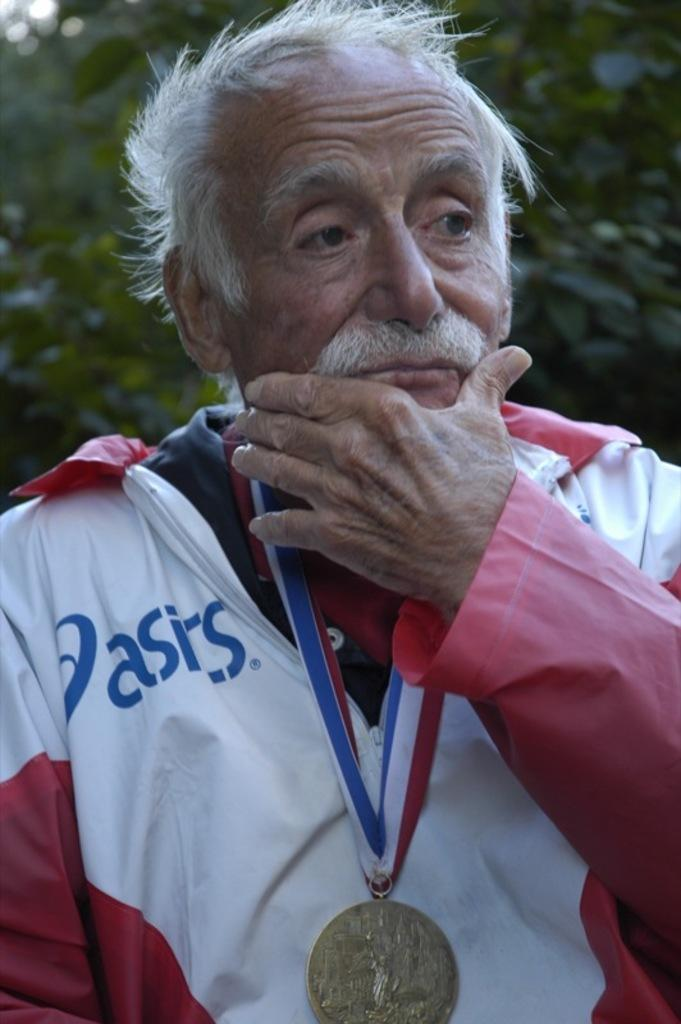<image>
Render a clear and concise summary of the photo. A man is wearing a medallion on a red, white and blue ribbon, over a jacket that says, "Oasis". 